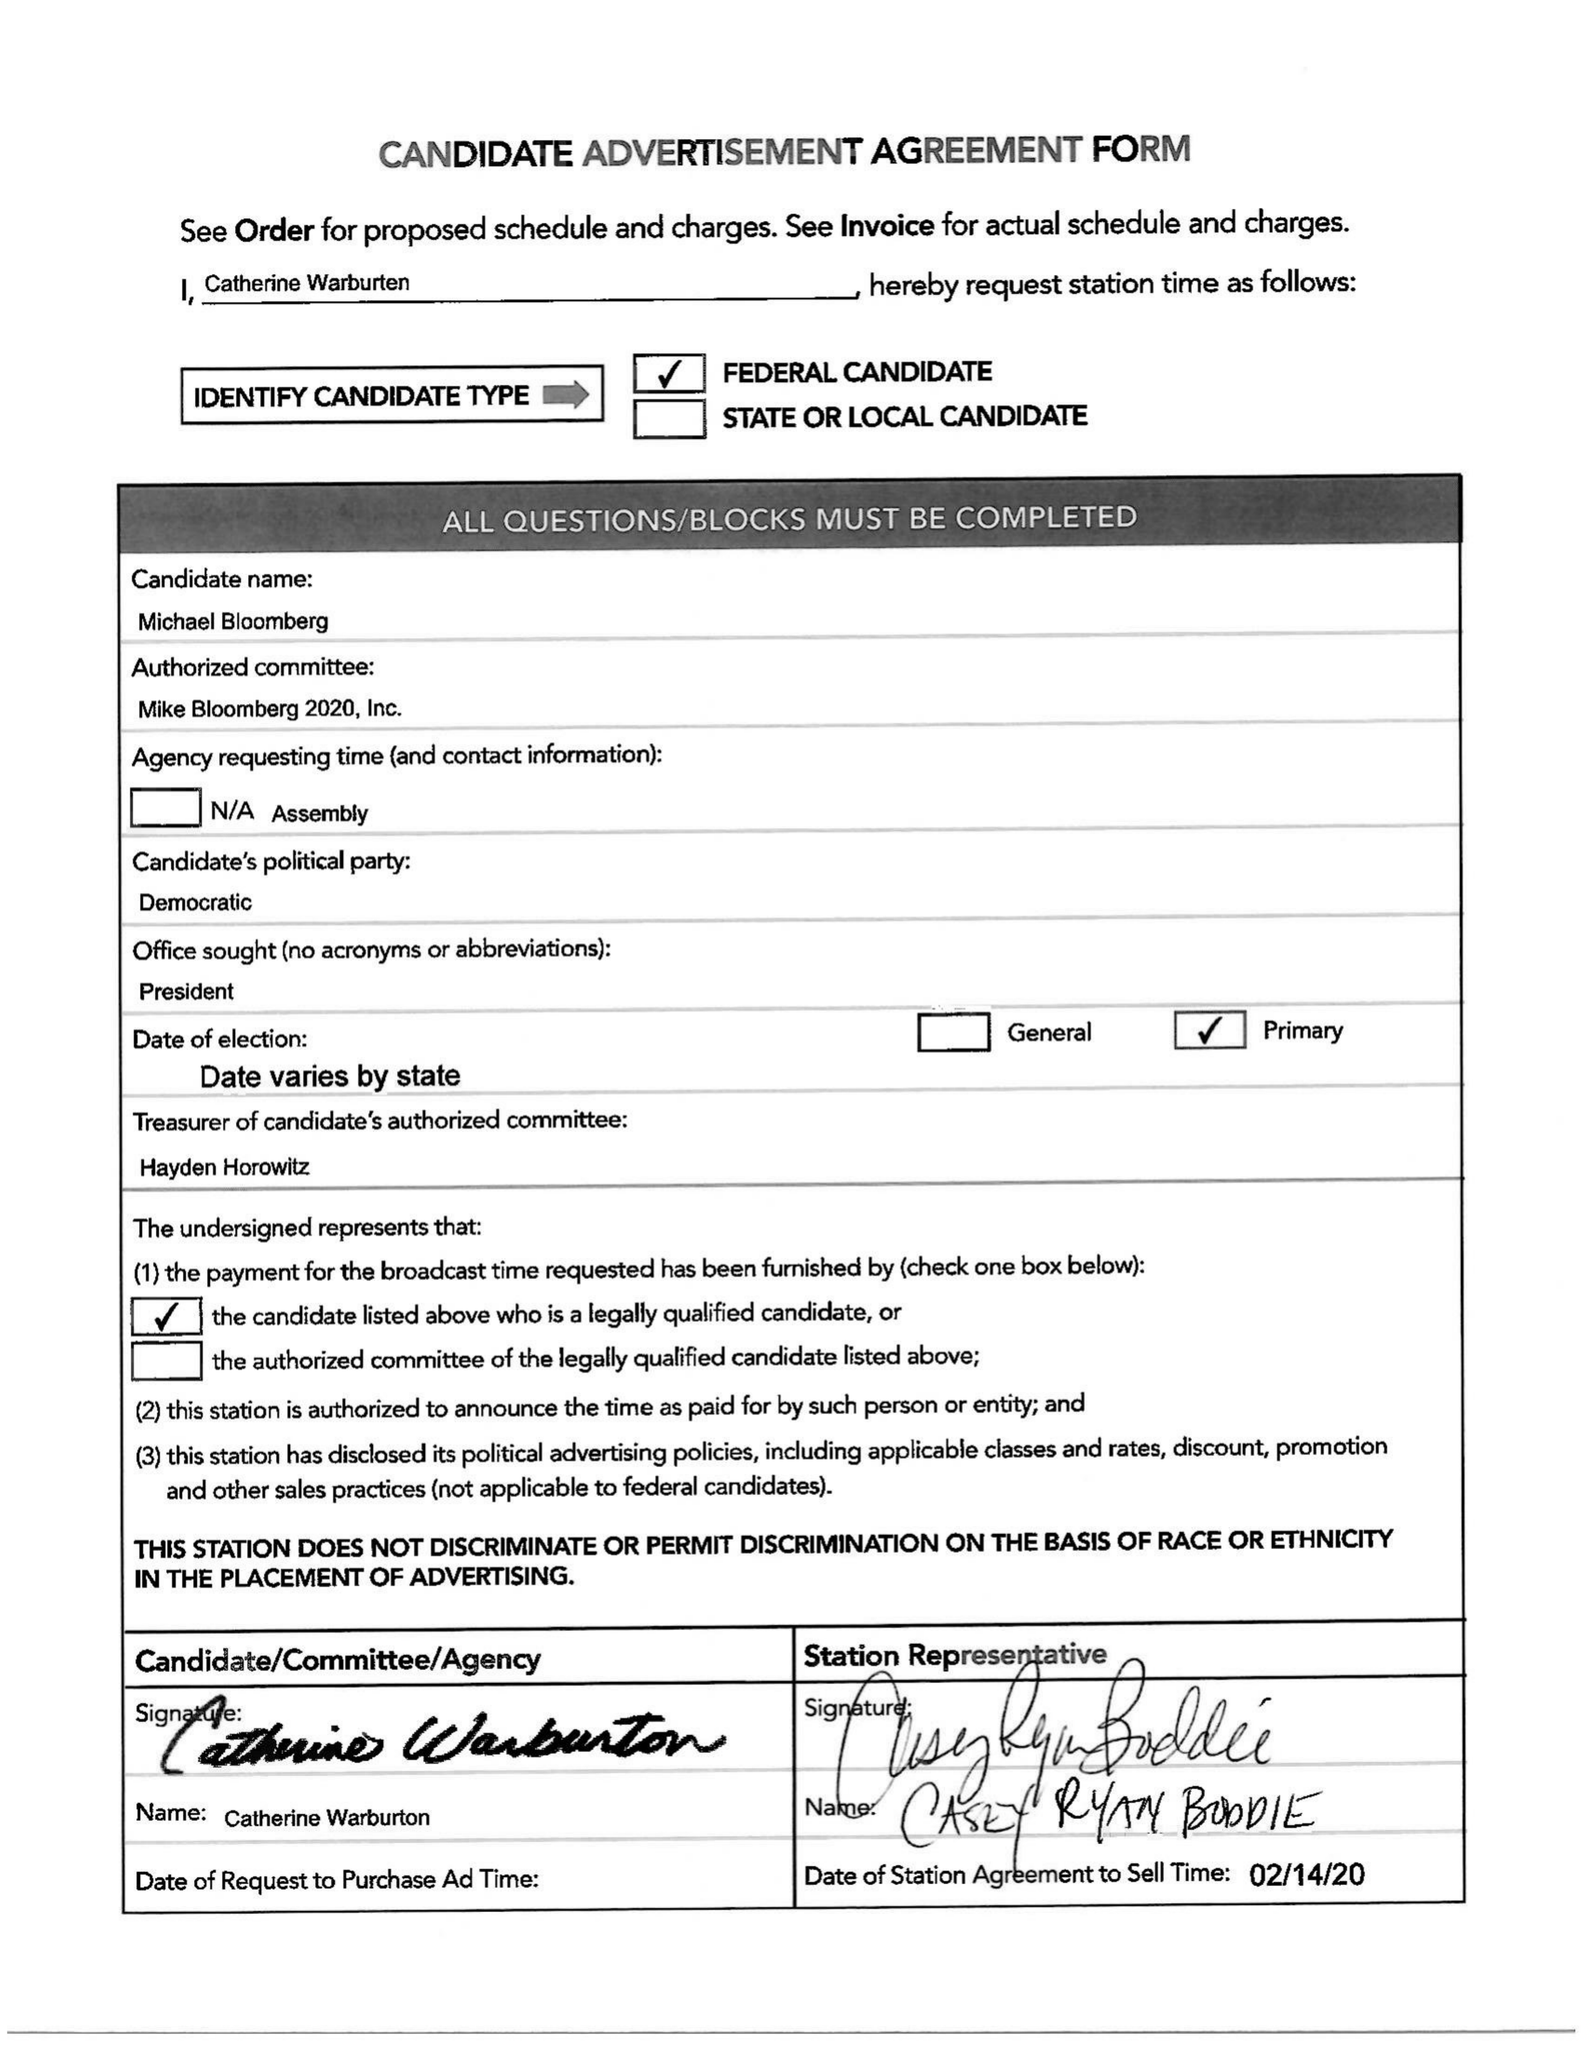What is the value for the advertiser?
Answer the question using a single word or phrase. MICHAEL BLOOMBERG FOR PRESIDENT OF THE UNITED STATES OF AMERICA 